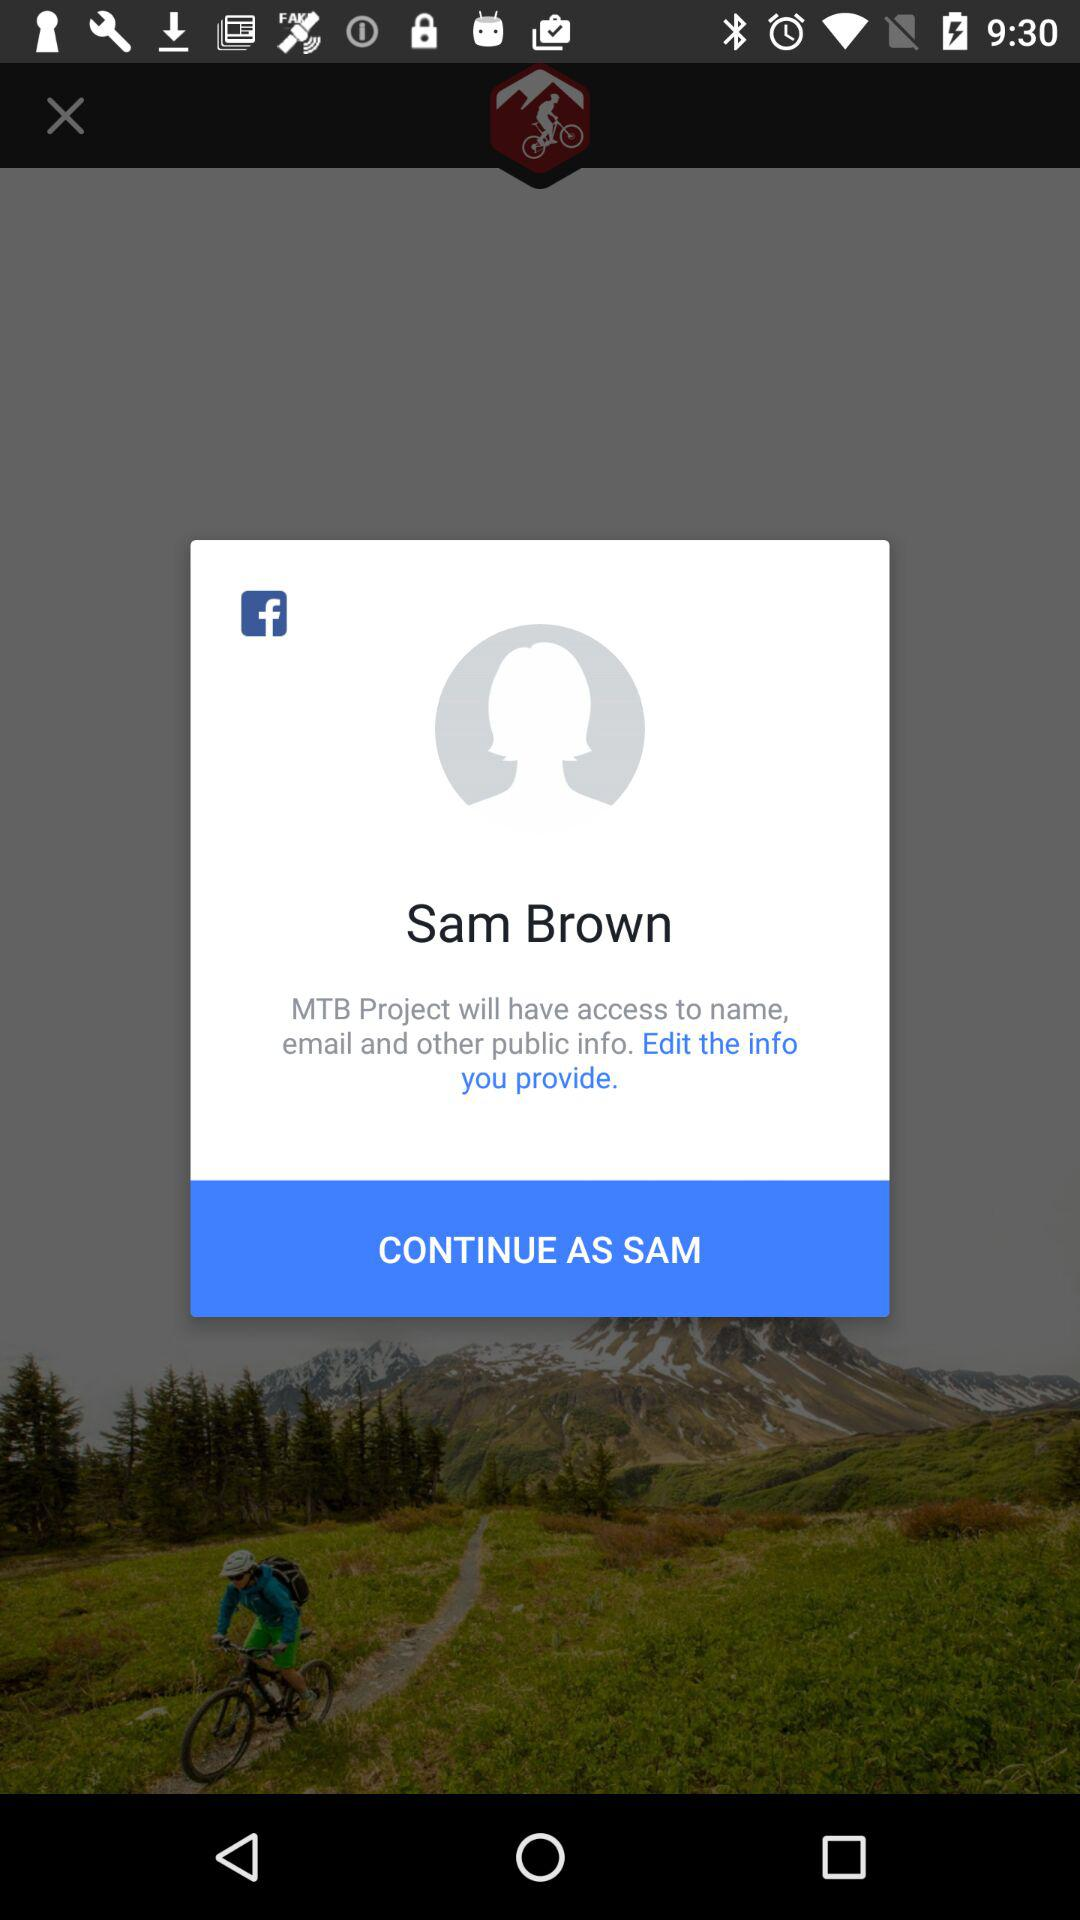What application will have access to the name, email and other public info.? The application "MTB Project" will have access to the name, email and other public info. 